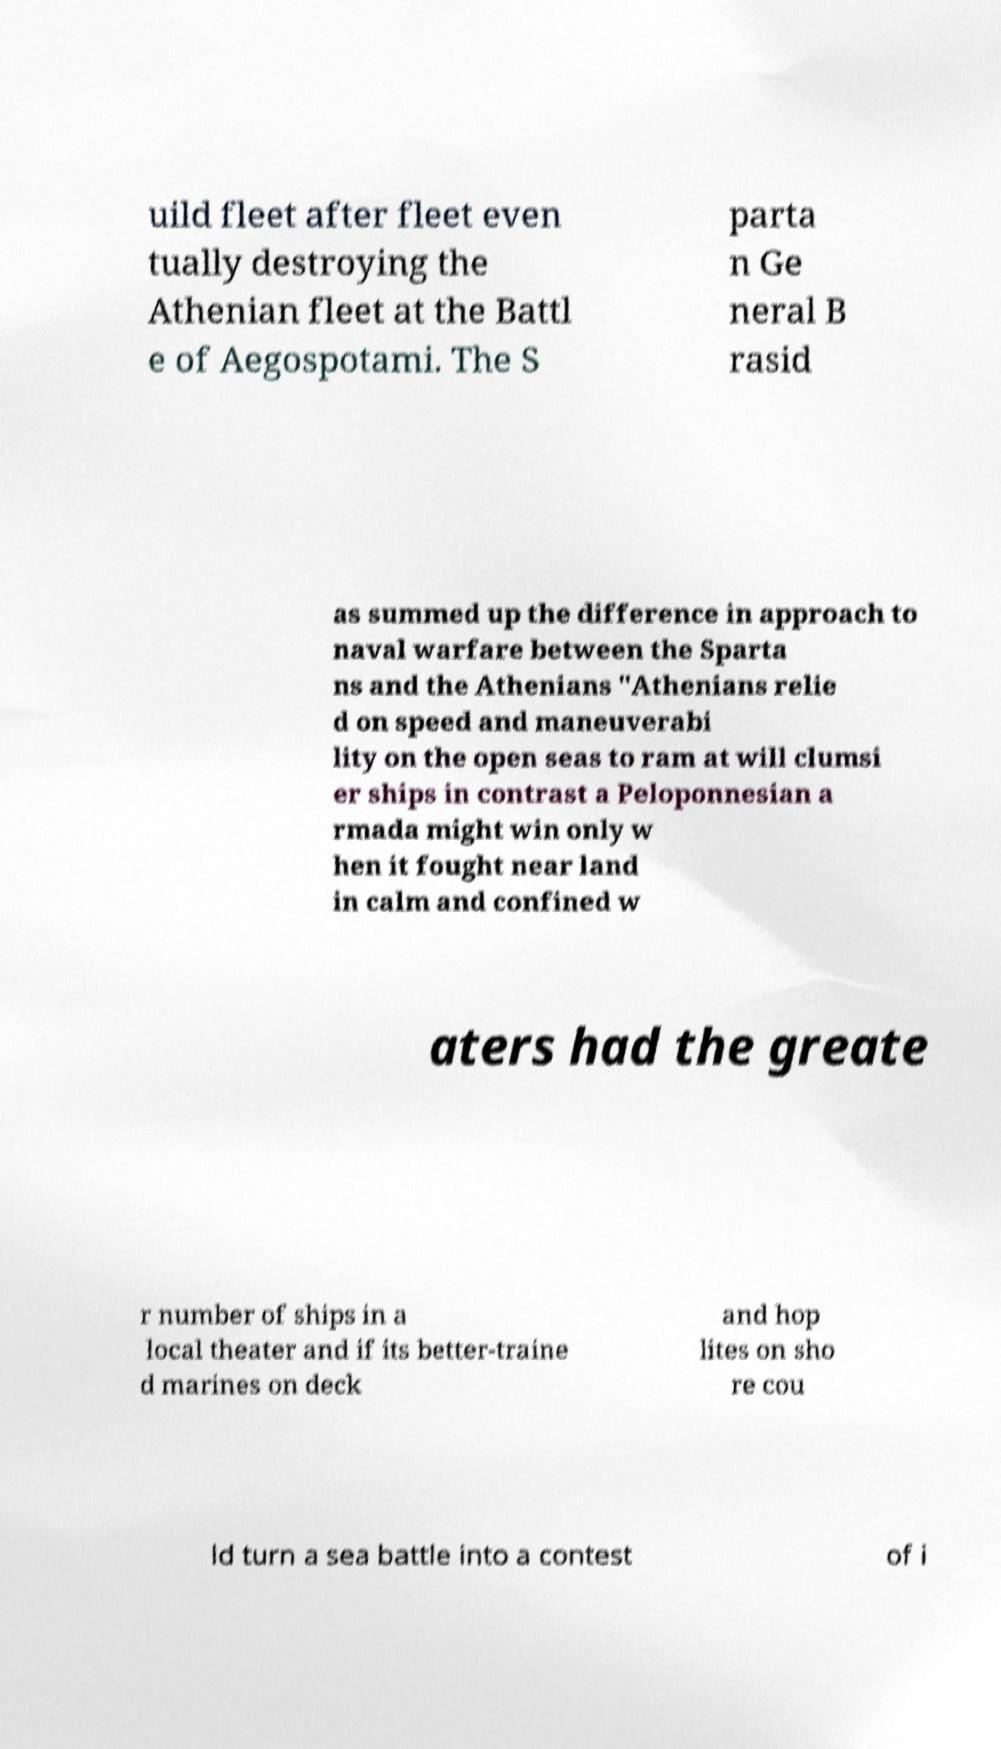There's text embedded in this image that I need extracted. Can you transcribe it verbatim? uild fleet after fleet even tually destroying the Athenian fleet at the Battl e of Aegospotami. The S parta n Ge neral B rasid as summed up the difference in approach to naval warfare between the Sparta ns and the Athenians "Athenians relie d on speed and maneuverabi lity on the open seas to ram at will clumsi er ships in contrast a Peloponnesian a rmada might win only w hen it fought near land in calm and confined w aters had the greate r number of ships in a local theater and if its better-traine d marines on deck and hop lites on sho re cou ld turn a sea battle into a contest of i 